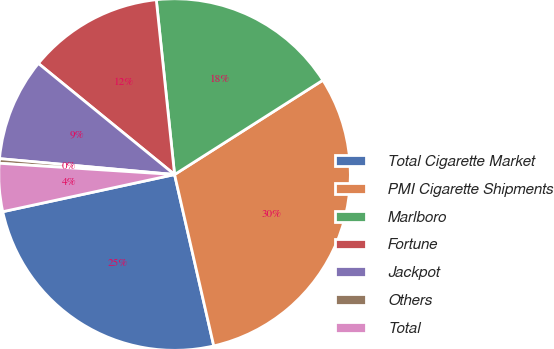Convert chart. <chart><loc_0><loc_0><loc_500><loc_500><pie_chart><fcel>Total Cigarette Market<fcel>PMI Cigarette Shipments<fcel>Marlboro<fcel>Fortune<fcel>Jackpot<fcel>Others<fcel>Total<nl><fcel>25.19%<fcel>30.44%<fcel>17.64%<fcel>12.45%<fcel>9.45%<fcel>0.42%<fcel>4.41%<nl></chart> 